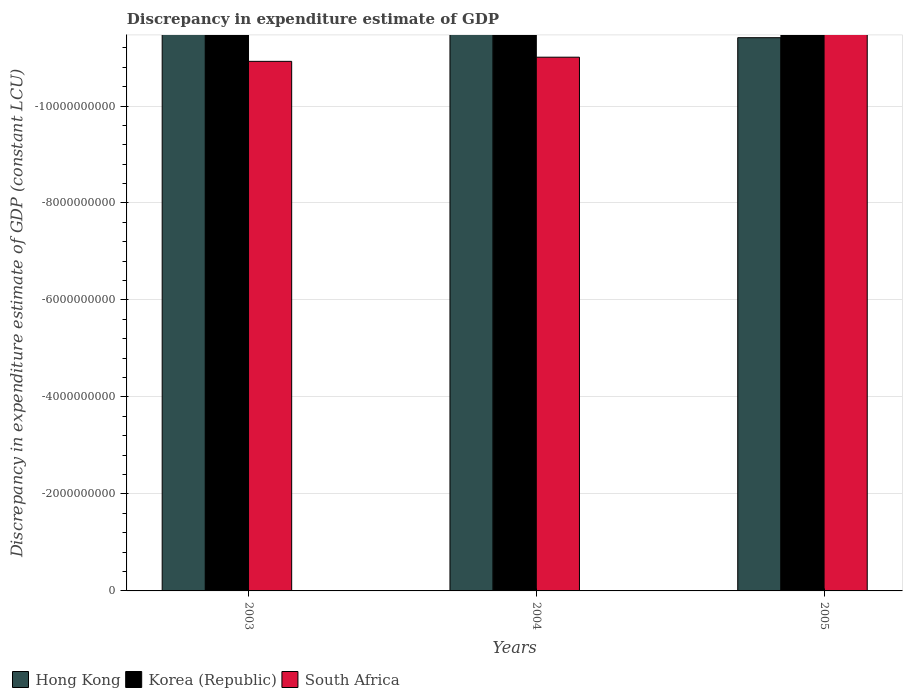Are the number of bars per tick equal to the number of legend labels?
Offer a very short reply. No. Are the number of bars on each tick of the X-axis equal?
Your answer should be compact. Yes. What is the label of the 3rd group of bars from the left?
Your answer should be compact. 2005. In how many cases, is the number of bars for a given year not equal to the number of legend labels?
Offer a very short reply. 3. What is the discrepancy in expenditure estimate of GDP in Hong Kong in 2003?
Offer a terse response. 0. Across all years, what is the minimum discrepancy in expenditure estimate of GDP in South Africa?
Offer a very short reply. 0. What is the difference between the discrepancy in expenditure estimate of GDP in South Africa in 2005 and the discrepancy in expenditure estimate of GDP in Hong Kong in 2004?
Ensure brevity in your answer.  0. What is the average discrepancy in expenditure estimate of GDP in Korea (Republic) per year?
Your answer should be very brief. 0. Is it the case that in every year, the sum of the discrepancy in expenditure estimate of GDP in Korea (Republic) and discrepancy in expenditure estimate of GDP in South Africa is greater than the discrepancy in expenditure estimate of GDP in Hong Kong?
Ensure brevity in your answer.  No. How many bars are there?
Make the answer very short. 0. How many years are there in the graph?
Offer a terse response. 3. What is the difference between two consecutive major ticks on the Y-axis?
Offer a very short reply. 2.00e+09. Does the graph contain any zero values?
Your response must be concise. Yes. Does the graph contain grids?
Give a very brief answer. Yes. What is the title of the graph?
Your answer should be very brief. Discrepancy in expenditure estimate of GDP. What is the label or title of the X-axis?
Your answer should be compact. Years. What is the label or title of the Y-axis?
Provide a short and direct response. Discrepancy in expenditure estimate of GDP (constant LCU). What is the Discrepancy in expenditure estimate of GDP (constant LCU) in South Africa in 2003?
Give a very brief answer. 0. What is the Discrepancy in expenditure estimate of GDP (constant LCU) of Hong Kong in 2004?
Provide a succinct answer. 0. What is the Discrepancy in expenditure estimate of GDP (constant LCU) in Korea (Republic) in 2004?
Your response must be concise. 0. What is the Discrepancy in expenditure estimate of GDP (constant LCU) of South Africa in 2004?
Offer a terse response. 0. What is the Discrepancy in expenditure estimate of GDP (constant LCU) in Korea (Republic) in 2005?
Give a very brief answer. 0. What is the total Discrepancy in expenditure estimate of GDP (constant LCU) of Hong Kong in the graph?
Provide a short and direct response. 0. What is the average Discrepancy in expenditure estimate of GDP (constant LCU) in South Africa per year?
Provide a succinct answer. 0. 